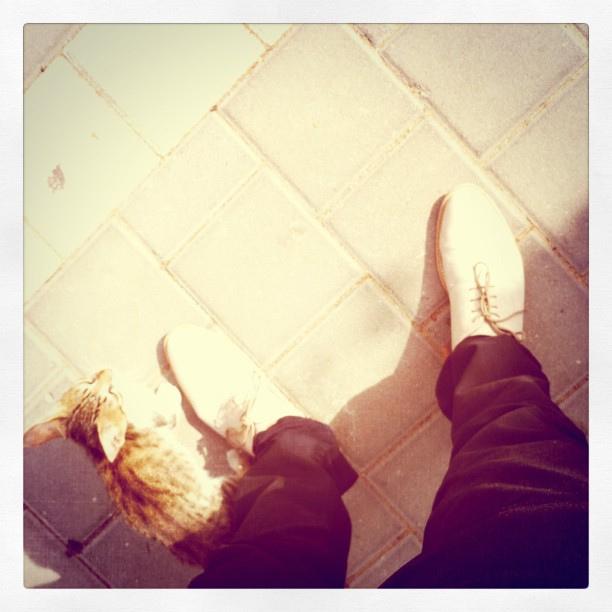What is the cat doing?
Concise answer only. Standing. Are they standing on a ceramic tile floor?
Keep it brief. Yes. Why can we see through the persons feet?
Keep it brief. Lighting. Are the cat's ears larger than a normal cat's?
Answer briefly. No. 